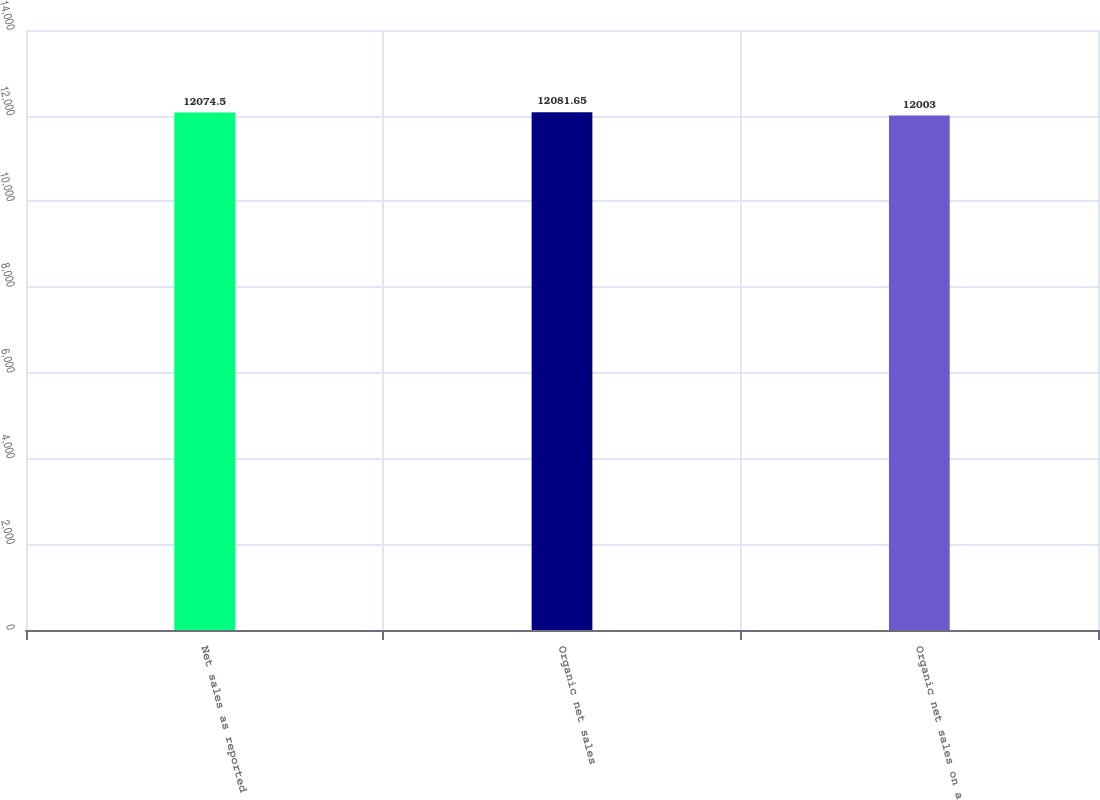Convert chart. <chart><loc_0><loc_0><loc_500><loc_500><bar_chart><fcel>Net sales as reported<fcel>Organic net sales<fcel>Organic net sales on a<nl><fcel>12074.5<fcel>12081.6<fcel>12003<nl></chart> 